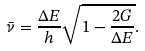Convert formula to latex. <formula><loc_0><loc_0><loc_500><loc_500>\bar { \nu } = \frac { \Delta E } { h } \sqrt { 1 - \frac { 2 G } { \Delta E } } .</formula> 